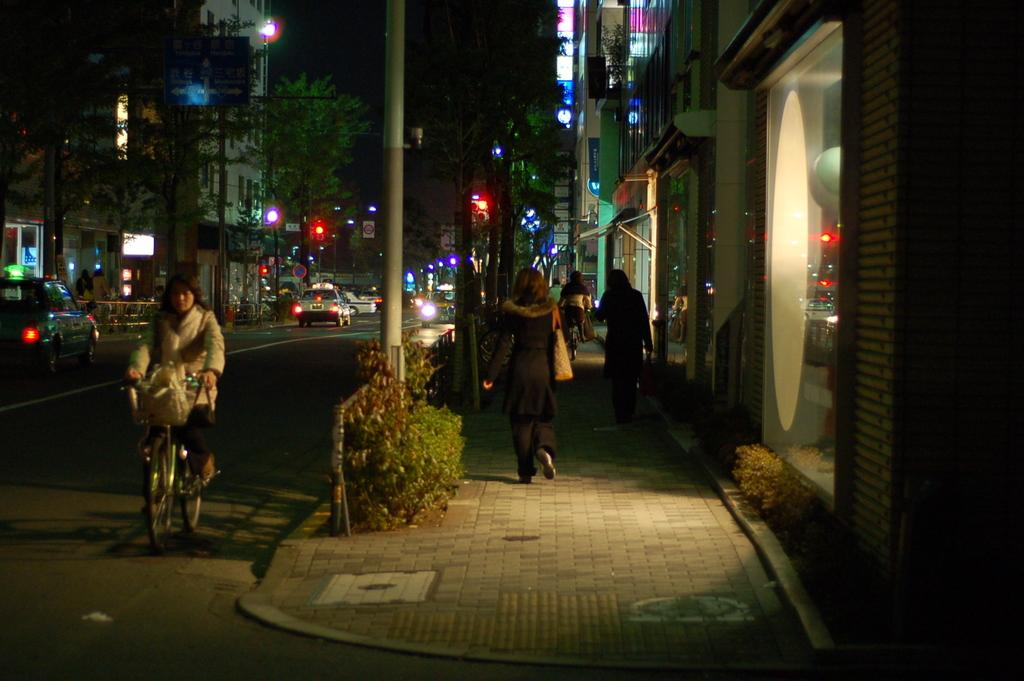What are the women in the image doing? There are two women walking in the street in the image. What is happening beside the women? There is a woman riding a bicycle beside them. What can be seen in the background of the image? There are cars, trees, and buildings in the background. What type of government attraction is present in the image? There is no government attraction present in the image. What adjustments are the women making to their walking speed? The image does not provide information about the women's walking speed or any adjustments they might be making. 